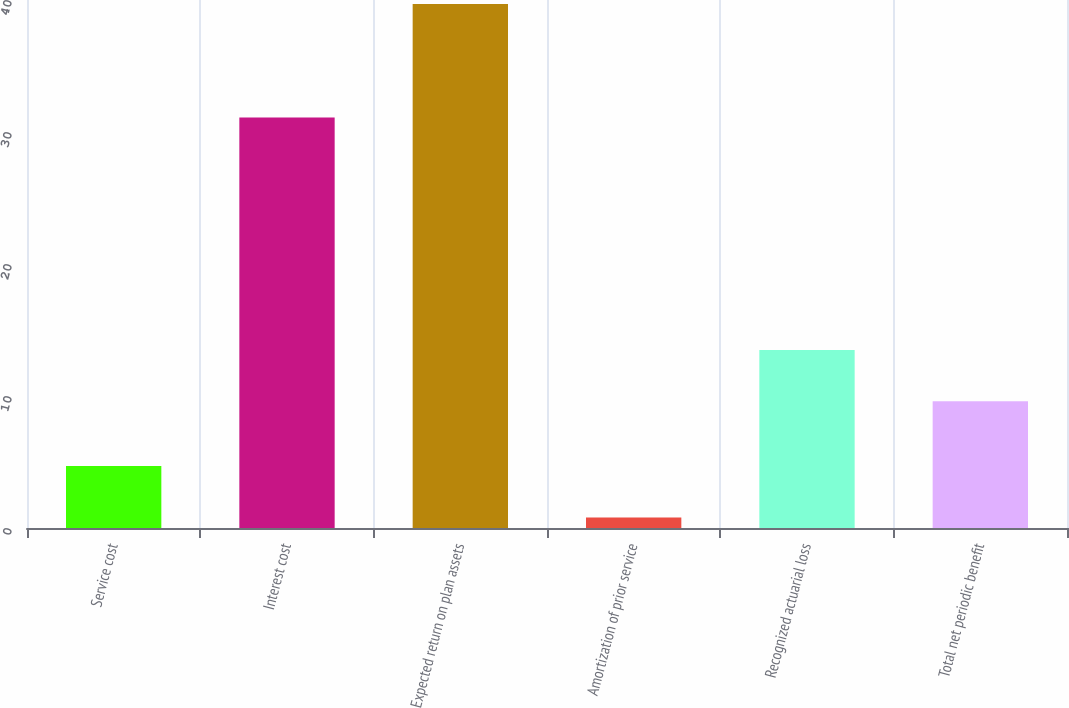<chart> <loc_0><loc_0><loc_500><loc_500><bar_chart><fcel>Service cost<fcel>Interest cost<fcel>Expected return on plan assets<fcel>Amortization of prior service<fcel>Recognized actuarial loss<fcel>Total net periodic benefit<nl><fcel>4.69<fcel>31.1<fcel>39.7<fcel>0.8<fcel>13.49<fcel>9.6<nl></chart> 